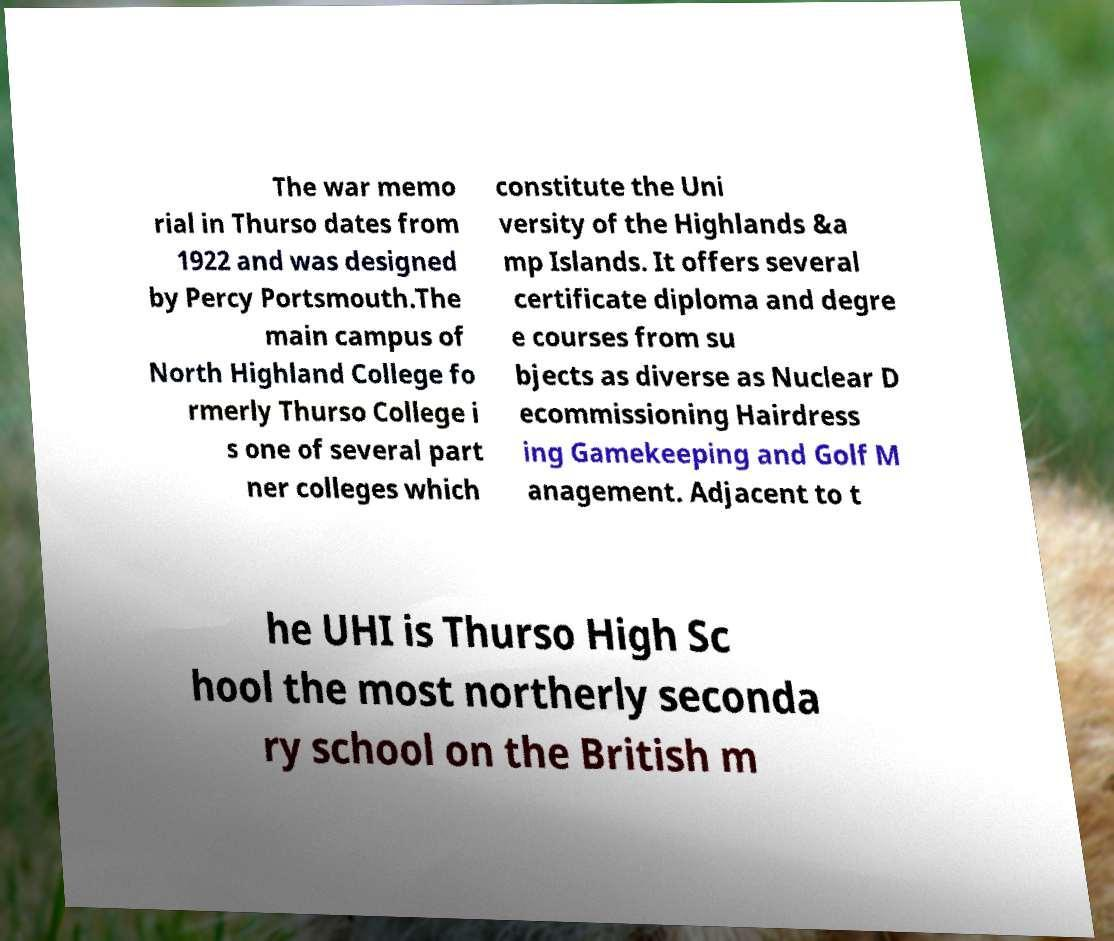Can you read and provide the text displayed in the image?This photo seems to have some interesting text. Can you extract and type it out for me? The war memo rial in Thurso dates from 1922 and was designed by Percy Portsmouth.The main campus of North Highland College fo rmerly Thurso College i s one of several part ner colleges which constitute the Uni versity of the Highlands &a mp Islands. It offers several certificate diploma and degre e courses from su bjects as diverse as Nuclear D ecommissioning Hairdress ing Gamekeeping and Golf M anagement. Adjacent to t he UHI is Thurso High Sc hool the most northerly seconda ry school on the British m 